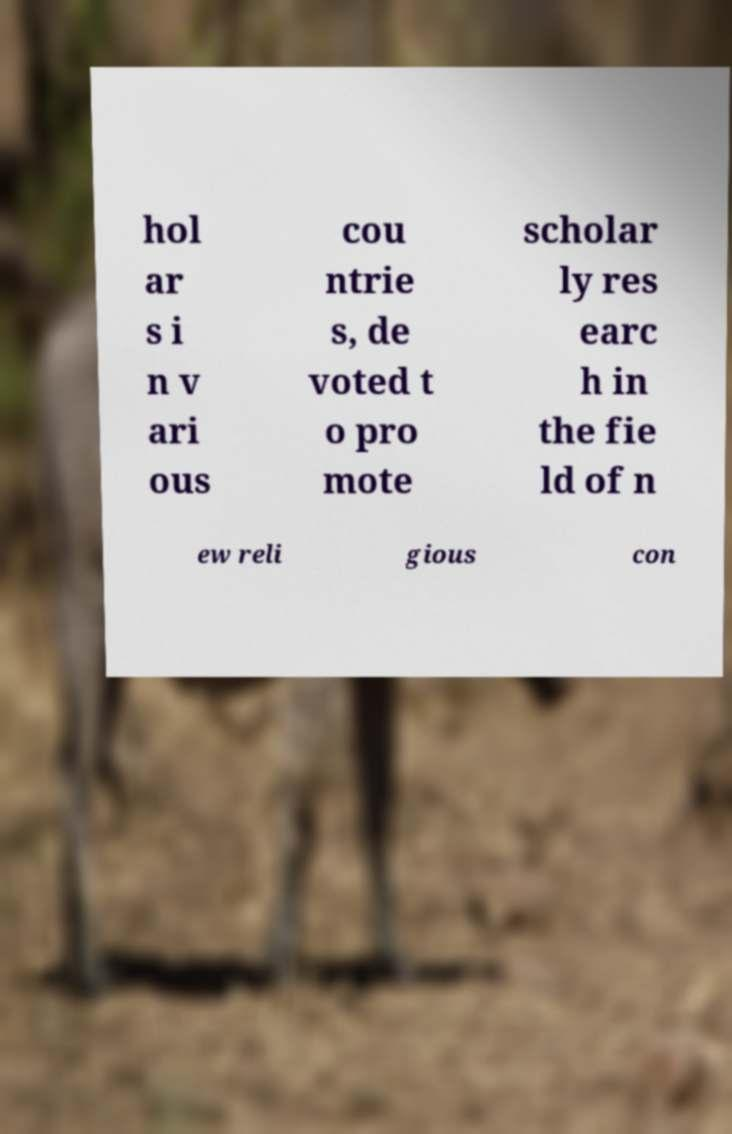For documentation purposes, I need the text within this image transcribed. Could you provide that? hol ar s i n v ari ous cou ntrie s, de voted t o pro mote scholar ly res earc h in the fie ld of n ew reli gious con 